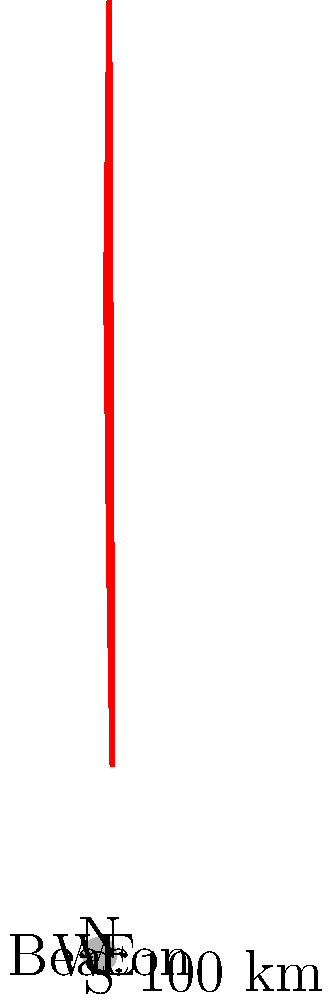Your aunt's letters describe an early radio navigation beacon with variable coverage due to terrain and atmospheric conditions. The coverage area is represented in polar coordinates as follows: $r = 4$ at $\theta = 60°$, $r = 3$ at $\theta = 120°$, $r = 2$ at $\theta = 210°$, and $r = 3$ at $\theta = 300°$, where $r$ is in units of 100 km. What is the total area covered by this beacon in square kilometers? To find the area covered by the beacon, we need to use the formula for the area of a sector in polar coordinates and apply it to each section of the coverage area. The formula is:

$$A = \frac{1}{2} \int_{\theta_1}^{\theta_2} r^2(\theta) d\theta$$

Let's break it down step-by-step:

1) First, we need to find the function $r(\theta)$ for each section. We can use linear interpolation between the given points.

2) We'll divide the area into four sections:
   Section 1: $60° \leq \theta \leq 120°$
   Section 2: $120° \leq \theta \leq 210°$
   Section 3: $210° \leq \theta \leq 300°$
   Section 4: $300° \leq \theta \leq 60°$ (wrapping around to the start)

3) For each section, we'll use the linear function:
   $r(\theta) = m\theta + b$, where $m$ is the slope and $b$ is the y-intercept.

4) Calculating for each section:

   Section 1: $r(\theta) = -\frac{1}{60}\theta + 5$
   $A_1 = \frac{1}{2} \int_{60}^{120} (-\frac{1}{60}\theta + 5)^2 d\theta \approx 9,899.56$ km²

   Section 2: $r(\theta) = -\frac{1}{90}\theta + \frac{13}{3}$
   $A_2 = \frac{1}{2} \int_{120}^{210} (-\frac{1}{90}\theta + \frac{13}{3})^2 d\theta \approx 11,259.29$ km²

   Section 3: $r(\theta) = \frac{1}{90}\theta - \frac{1}{3}$
   $A_3 = \frac{1}{2} \int_{210}^{300} (\frac{1}{90}\theta - \frac{1}{3})^2 d\theta \approx 11,259.29$ km²

   Section 4: $r(\theta) = \frac{1}{60}\theta - 1$
   $A_4 = \frac{1}{2} \int_{300}^{420} (\frac{1}{60}\theta - 1)^2 d\theta \approx 19,799.12$ km²

5) The total area is the sum of these four sections:
   $A_{total} = A_1 + A_2 + A_3 + A_4 \approx 52,217.26$ km²
Answer: 52,217 km² 